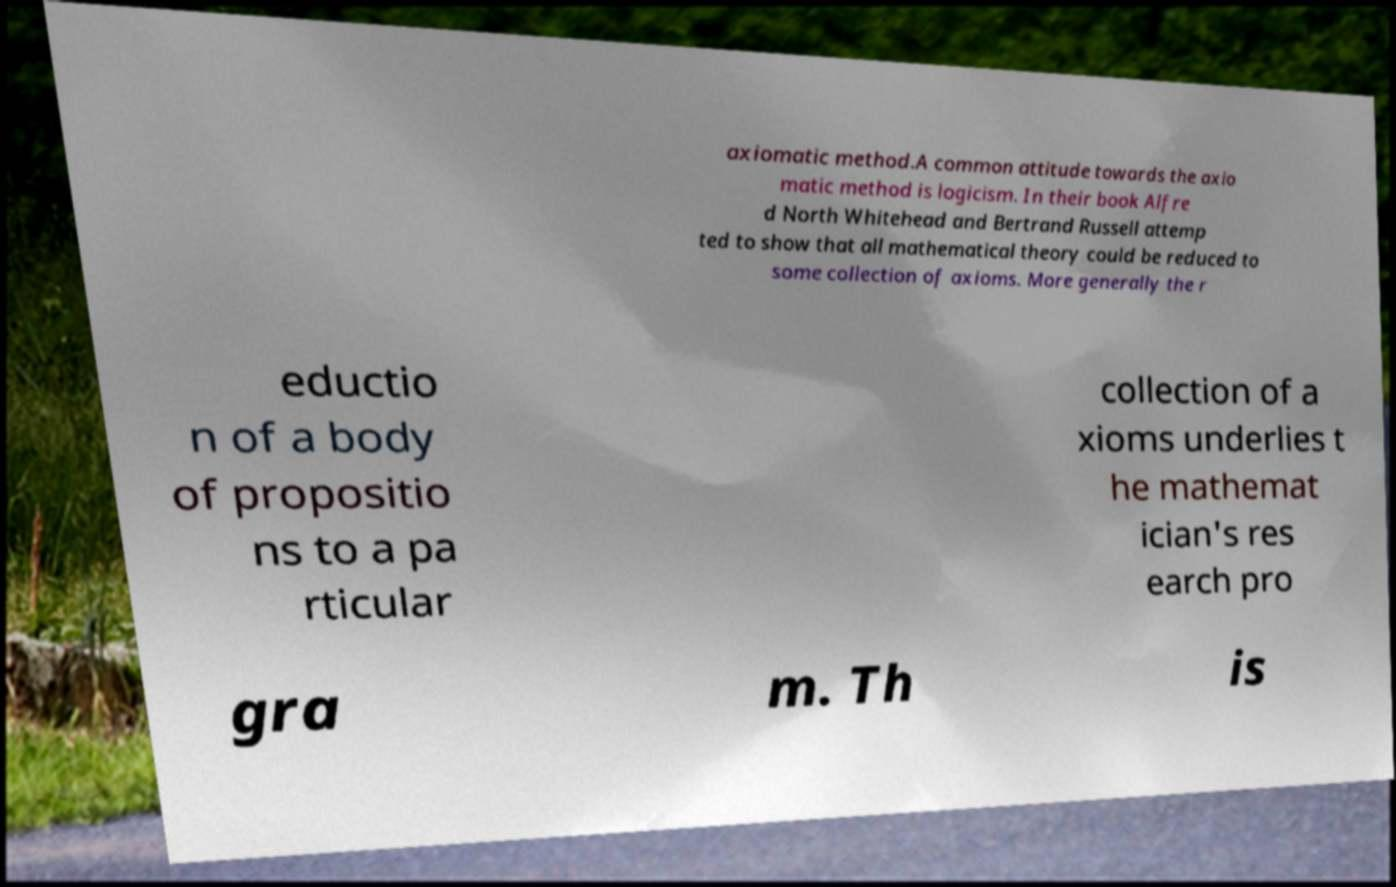Please identify and transcribe the text found in this image. axiomatic method.A common attitude towards the axio matic method is logicism. In their book Alfre d North Whitehead and Bertrand Russell attemp ted to show that all mathematical theory could be reduced to some collection of axioms. More generally the r eductio n of a body of propositio ns to a pa rticular collection of a xioms underlies t he mathemat ician's res earch pro gra m. Th is 